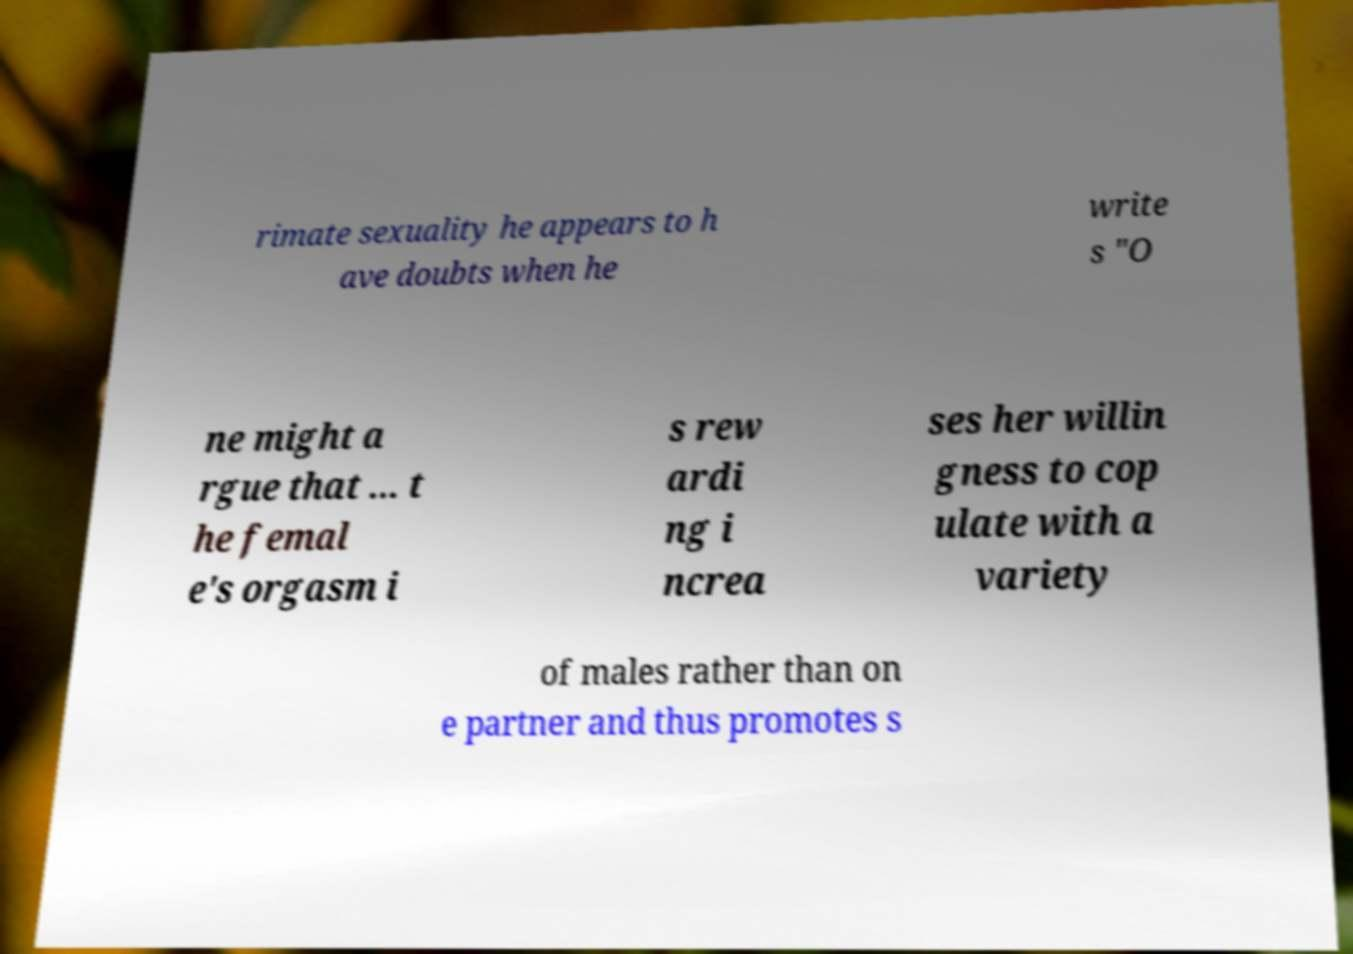Could you assist in decoding the text presented in this image and type it out clearly? rimate sexuality he appears to h ave doubts when he write s "O ne might a rgue that ... t he femal e's orgasm i s rew ardi ng i ncrea ses her willin gness to cop ulate with a variety of males rather than on e partner and thus promotes s 